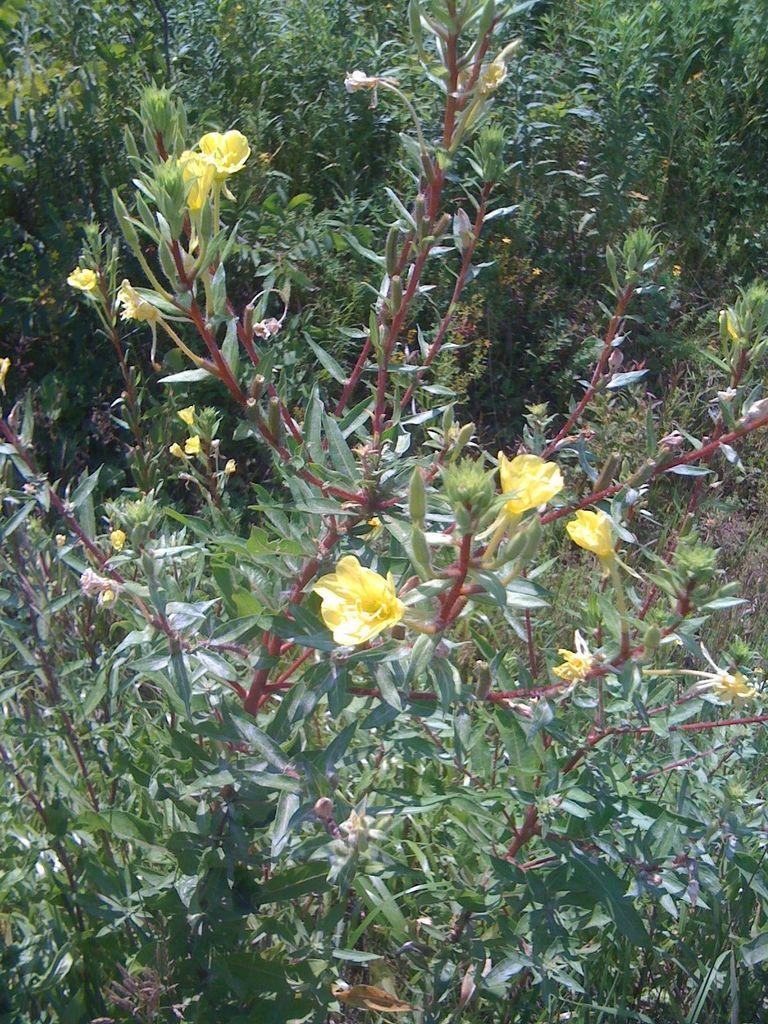What is in the foreground of the image? There are flowers in the foreground of the image. What is the flowers associated with? The flowers are associated with a plant. What can be seen in the background of the image? There are plants visible in the background of the image. What book is the representative reading in the image? There is no representative or book present in the image; it features flowers and plants. 